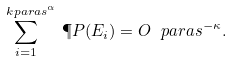<formula> <loc_0><loc_0><loc_500><loc_500>\sum _ { i = 1 } ^ { \ k p a r a { s ^ { \alpha } } } \, \P P ( E _ { i } ) = O \ p a r a { s ^ { - \kappa } } .</formula> 